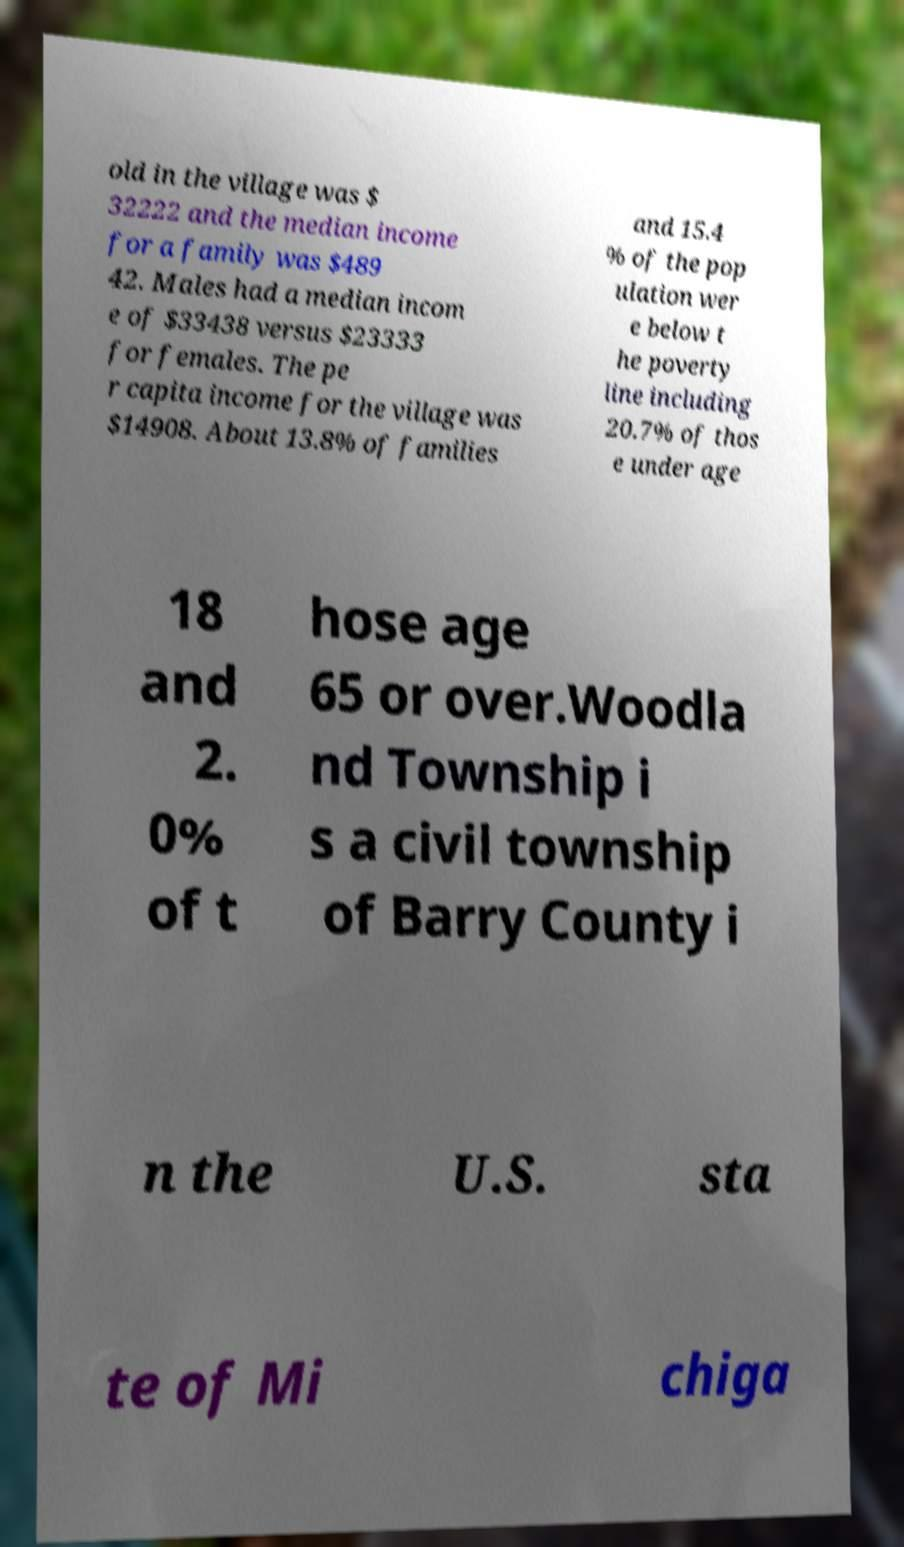Could you assist in decoding the text presented in this image and type it out clearly? old in the village was $ 32222 and the median income for a family was $489 42. Males had a median incom e of $33438 versus $23333 for females. The pe r capita income for the village was $14908. About 13.8% of families and 15.4 % of the pop ulation wer e below t he poverty line including 20.7% of thos e under age 18 and 2. 0% of t hose age 65 or over.Woodla nd Township i s a civil township of Barry County i n the U.S. sta te of Mi chiga 